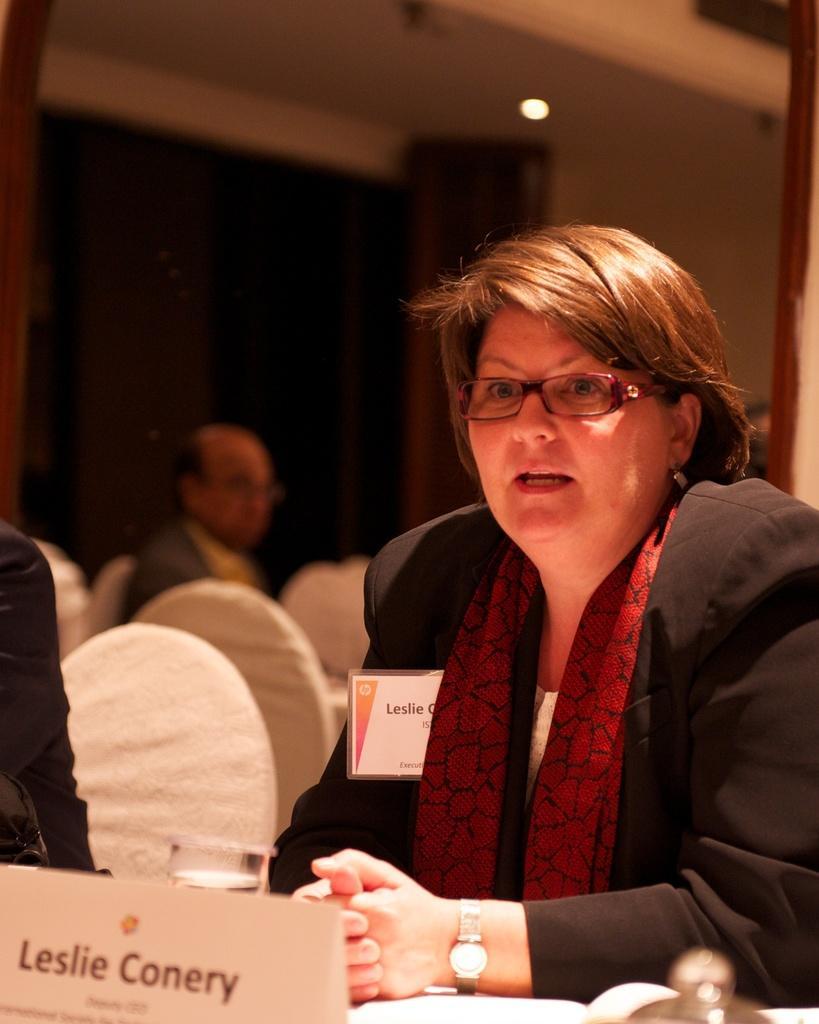How would you summarize this image in a sentence or two? In this image there is a person sitting on the chair, there is a board with the person's name on it, there is a person truncated to the left of the image, there is a glass on the surface, there is water in the glass, there are cars, there is light, the background of the image is dark. 